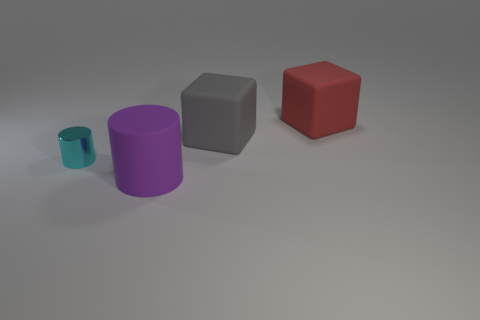Add 3 yellow metal objects. How many objects exist? 7 Subtract 1 cylinders. How many cylinders are left? 1 Add 4 matte objects. How many matte objects are left? 7 Add 4 tiny cyan metal things. How many tiny cyan metal things exist? 5 Subtract all gray cubes. How many cubes are left? 1 Subtract 0 blue cubes. How many objects are left? 4 Subtract all gray blocks. Subtract all cyan balls. How many blocks are left? 1 Subtract all yellow cylinders. How many green blocks are left? 0 Subtract all purple rubber cylinders. Subtract all big cylinders. How many objects are left? 2 